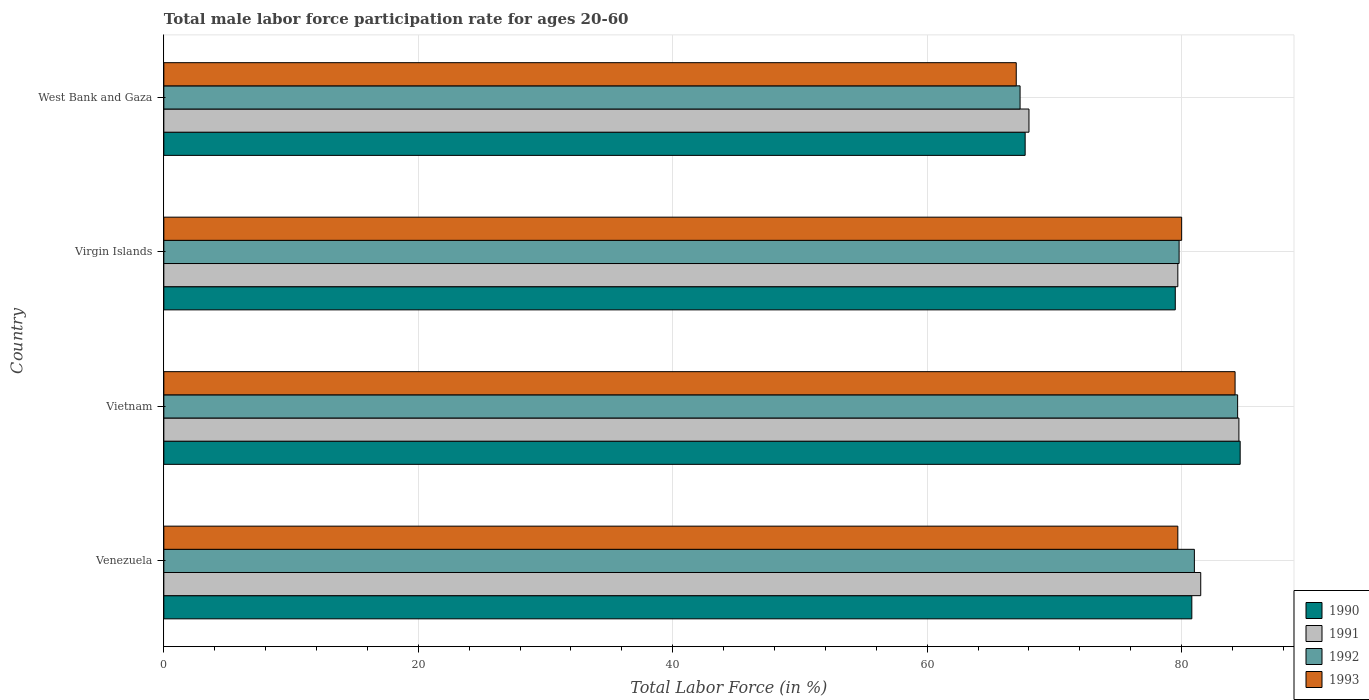How many bars are there on the 4th tick from the top?
Your response must be concise. 4. How many bars are there on the 4th tick from the bottom?
Your response must be concise. 4. What is the label of the 2nd group of bars from the top?
Your answer should be very brief. Virgin Islands. What is the male labor force participation rate in 1993 in Vietnam?
Give a very brief answer. 84.2. Across all countries, what is the maximum male labor force participation rate in 1992?
Give a very brief answer. 84.4. In which country was the male labor force participation rate in 1991 maximum?
Your response must be concise. Vietnam. In which country was the male labor force participation rate in 1992 minimum?
Your response must be concise. West Bank and Gaza. What is the total male labor force participation rate in 1990 in the graph?
Keep it short and to the point. 312.6. What is the difference between the male labor force participation rate in 1993 in Virgin Islands and that in West Bank and Gaza?
Make the answer very short. 13. What is the difference between the male labor force participation rate in 1992 in Virgin Islands and the male labor force participation rate in 1993 in Venezuela?
Your answer should be very brief. 0.1. What is the average male labor force participation rate in 1993 per country?
Give a very brief answer. 77.72. What is the difference between the male labor force participation rate in 1991 and male labor force participation rate in 1993 in Venezuela?
Make the answer very short. 1.8. What is the ratio of the male labor force participation rate in 1993 in Vietnam to that in Virgin Islands?
Offer a very short reply. 1.05. Is the male labor force participation rate in 1990 in Vietnam less than that in Virgin Islands?
Provide a short and direct response. No. Is the difference between the male labor force participation rate in 1991 in Venezuela and Vietnam greater than the difference between the male labor force participation rate in 1993 in Venezuela and Vietnam?
Give a very brief answer. Yes. What is the difference between the highest and the second highest male labor force participation rate in 1991?
Offer a very short reply. 3. What is the difference between the highest and the lowest male labor force participation rate in 1993?
Your response must be concise. 17.2. Is it the case that in every country, the sum of the male labor force participation rate in 1992 and male labor force participation rate in 1993 is greater than the male labor force participation rate in 1990?
Ensure brevity in your answer.  Yes. Are all the bars in the graph horizontal?
Provide a succinct answer. Yes. How many countries are there in the graph?
Provide a short and direct response. 4. Are the values on the major ticks of X-axis written in scientific E-notation?
Ensure brevity in your answer.  No. Does the graph contain any zero values?
Offer a very short reply. No. Does the graph contain grids?
Offer a very short reply. Yes. Where does the legend appear in the graph?
Make the answer very short. Bottom right. How many legend labels are there?
Your answer should be very brief. 4. What is the title of the graph?
Your answer should be very brief. Total male labor force participation rate for ages 20-60. What is the label or title of the X-axis?
Ensure brevity in your answer.  Total Labor Force (in %). What is the label or title of the Y-axis?
Offer a very short reply. Country. What is the Total Labor Force (in %) in 1990 in Venezuela?
Give a very brief answer. 80.8. What is the Total Labor Force (in %) of 1991 in Venezuela?
Offer a very short reply. 81.5. What is the Total Labor Force (in %) in 1992 in Venezuela?
Your answer should be compact. 81. What is the Total Labor Force (in %) of 1993 in Venezuela?
Offer a very short reply. 79.7. What is the Total Labor Force (in %) in 1990 in Vietnam?
Offer a very short reply. 84.6. What is the Total Labor Force (in %) in 1991 in Vietnam?
Offer a terse response. 84.5. What is the Total Labor Force (in %) of 1992 in Vietnam?
Provide a short and direct response. 84.4. What is the Total Labor Force (in %) of 1993 in Vietnam?
Your answer should be compact. 84.2. What is the Total Labor Force (in %) of 1990 in Virgin Islands?
Provide a succinct answer. 79.5. What is the Total Labor Force (in %) in 1991 in Virgin Islands?
Give a very brief answer. 79.7. What is the Total Labor Force (in %) in 1992 in Virgin Islands?
Your answer should be very brief. 79.8. What is the Total Labor Force (in %) of 1990 in West Bank and Gaza?
Offer a very short reply. 67.7. What is the Total Labor Force (in %) of 1991 in West Bank and Gaza?
Your answer should be compact. 68. What is the Total Labor Force (in %) of 1992 in West Bank and Gaza?
Provide a succinct answer. 67.3. Across all countries, what is the maximum Total Labor Force (in %) of 1990?
Give a very brief answer. 84.6. Across all countries, what is the maximum Total Labor Force (in %) of 1991?
Make the answer very short. 84.5. Across all countries, what is the maximum Total Labor Force (in %) in 1992?
Your answer should be compact. 84.4. Across all countries, what is the maximum Total Labor Force (in %) in 1993?
Provide a succinct answer. 84.2. Across all countries, what is the minimum Total Labor Force (in %) in 1990?
Offer a terse response. 67.7. Across all countries, what is the minimum Total Labor Force (in %) in 1992?
Make the answer very short. 67.3. What is the total Total Labor Force (in %) in 1990 in the graph?
Give a very brief answer. 312.6. What is the total Total Labor Force (in %) in 1991 in the graph?
Ensure brevity in your answer.  313.7. What is the total Total Labor Force (in %) in 1992 in the graph?
Ensure brevity in your answer.  312.5. What is the total Total Labor Force (in %) of 1993 in the graph?
Make the answer very short. 310.9. What is the difference between the Total Labor Force (in %) of 1990 in Venezuela and that in Vietnam?
Make the answer very short. -3.8. What is the difference between the Total Labor Force (in %) of 1991 in Venezuela and that in Virgin Islands?
Make the answer very short. 1.8. What is the difference between the Total Labor Force (in %) in 1992 in Venezuela and that in West Bank and Gaza?
Keep it short and to the point. 13.7. What is the difference between the Total Labor Force (in %) of 1993 in Venezuela and that in West Bank and Gaza?
Provide a short and direct response. 12.7. What is the difference between the Total Labor Force (in %) of 1991 in Vietnam and that in Virgin Islands?
Make the answer very short. 4.8. What is the difference between the Total Labor Force (in %) of 1992 in Vietnam and that in Virgin Islands?
Your answer should be compact. 4.6. What is the difference between the Total Labor Force (in %) of 1990 in Vietnam and that in West Bank and Gaza?
Provide a succinct answer. 16.9. What is the difference between the Total Labor Force (in %) of 1992 in Vietnam and that in West Bank and Gaza?
Offer a very short reply. 17.1. What is the difference between the Total Labor Force (in %) in 1990 in Virgin Islands and that in West Bank and Gaza?
Offer a terse response. 11.8. What is the difference between the Total Labor Force (in %) in 1990 in Venezuela and the Total Labor Force (in %) in 1991 in Vietnam?
Keep it short and to the point. -3.7. What is the difference between the Total Labor Force (in %) of 1990 in Venezuela and the Total Labor Force (in %) of 1992 in Vietnam?
Offer a very short reply. -3.6. What is the difference between the Total Labor Force (in %) of 1990 in Venezuela and the Total Labor Force (in %) of 1993 in Vietnam?
Your answer should be very brief. -3.4. What is the difference between the Total Labor Force (in %) of 1991 in Venezuela and the Total Labor Force (in %) of 1993 in Vietnam?
Make the answer very short. -2.7. What is the difference between the Total Labor Force (in %) in 1992 in Venezuela and the Total Labor Force (in %) in 1993 in Vietnam?
Provide a succinct answer. -3.2. What is the difference between the Total Labor Force (in %) in 1990 in Venezuela and the Total Labor Force (in %) in 1991 in Virgin Islands?
Give a very brief answer. 1.1. What is the difference between the Total Labor Force (in %) in 1990 in Venezuela and the Total Labor Force (in %) in 1992 in Virgin Islands?
Your response must be concise. 1. What is the difference between the Total Labor Force (in %) of 1990 in Venezuela and the Total Labor Force (in %) of 1992 in West Bank and Gaza?
Ensure brevity in your answer.  13.5. What is the difference between the Total Labor Force (in %) in 1991 in Venezuela and the Total Labor Force (in %) in 1992 in West Bank and Gaza?
Offer a very short reply. 14.2. What is the difference between the Total Labor Force (in %) in 1990 in Vietnam and the Total Labor Force (in %) in 1992 in Virgin Islands?
Offer a terse response. 4.8. What is the difference between the Total Labor Force (in %) in 1990 in Vietnam and the Total Labor Force (in %) in 1993 in Virgin Islands?
Keep it short and to the point. 4.6. What is the difference between the Total Labor Force (in %) in 1991 in Vietnam and the Total Labor Force (in %) in 1992 in Virgin Islands?
Your response must be concise. 4.7. What is the difference between the Total Labor Force (in %) in 1992 in Vietnam and the Total Labor Force (in %) in 1993 in Virgin Islands?
Your answer should be compact. 4.4. What is the difference between the Total Labor Force (in %) in 1990 in Vietnam and the Total Labor Force (in %) in 1991 in West Bank and Gaza?
Ensure brevity in your answer.  16.6. What is the difference between the Total Labor Force (in %) of 1990 in Vietnam and the Total Labor Force (in %) of 1992 in West Bank and Gaza?
Keep it short and to the point. 17.3. What is the difference between the Total Labor Force (in %) in 1990 in Vietnam and the Total Labor Force (in %) in 1993 in West Bank and Gaza?
Keep it short and to the point. 17.6. What is the difference between the Total Labor Force (in %) in 1990 in Virgin Islands and the Total Labor Force (in %) in 1991 in West Bank and Gaza?
Provide a succinct answer. 11.5. What is the difference between the Total Labor Force (in %) in 1990 in Virgin Islands and the Total Labor Force (in %) in 1992 in West Bank and Gaza?
Your response must be concise. 12.2. What is the difference between the Total Labor Force (in %) in 1990 in Virgin Islands and the Total Labor Force (in %) in 1993 in West Bank and Gaza?
Give a very brief answer. 12.5. What is the difference between the Total Labor Force (in %) in 1991 in Virgin Islands and the Total Labor Force (in %) in 1992 in West Bank and Gaza?
Ensure brevity in your answer.  12.4. What is the difference between the Total Labor Force (in %) in 1991 in Virgin Islands and the Total Labor Force (in %) in 1993 in West Bank and Gaza?
Offer a terse response. 12.7. What is the difference between the Total Labor Force (in %) of 1992 in Virgin Islands and the Total Labor Force (in %) of 1993 in West Bank and Gaza?
Offer a terse response. 12.8. What is the average Total Labor Force (in %) of 1990 per country?
Give a very brief answer. 78.15. What is the average Total Labor Force (in %) of 1991 per country?
Give a very brief answer. 78.42. What is the average Total Labor Force (in %) in 1992 per country?
Provide a short and direct response. 78.12. What is the average Total Labor Force (in %) in 1993 per country?
Your answer should be very brief. 77.72. What is the difference between the Total Labor Force (in %) in 1990 and Total Labor Force (in %) in 1991 in Venezuela?
Your answer should be compact. -0.7. What is the difference between the Total Labor Force (in %) in 1991 and Total Labor Force (in %) in 1992 in Venezuela?
Offer a terse response. 0.5. What is the difference between the Total Labor Force (in %) of 1991 and Total Labor Force (in %) of 1993 in Venezuela?
Provide a short and direct response. 1.8. What is the difference between the Total Labor Force (in %) in 1990 and Total Labor Force (in %) in 1992 in Vietnam?
Offer a very short reply. 0.2. What is the difference between the Total Labor Force (in %) in 1992 and Total Labor Force (in %) in 1993 in Vietnam?
Offer a terse response. 0.2. What is the difference between the Total Labor Force (in %) of 1990 and Total Labor Force (in %) of 1991 in Virgin Islands?
Your answer should be compact. -0.2. What is the difference between the Total Labor Force (in %) of 1990 and Total Labor Force (in %) of 1993 in Virgin Islands?
Offer a very short reply. -0.5. What is the difference between the Total Labor Force (in %) of 1991 and Total Labor Force (in %) of 1993 in Virgin Islands?
Provide a short and direct response. -0.3. What is the difference between the Total Labor Force (in %) in 1990 and Total Labor Force (in %) in 1991 in West Bank and Gaza?
Provide a short and direct response. -0.3. What is the difference between the Total Labor Force (in %) of 1990 and Total Labor Force (in %) of 1992 in West Bank and Gaza?
Make the answer very short. 0.4. What is the difference between the Total Labor Force (in %) of 1991 and Total Labor Force (in %) of 1992 in West Bank and Gaza?
Your answer should be compact. 0.7. What is the difference between the Total Labor Force (in %) in 1991 and Total Labor Force (in %) in 1993 in West Bank and Gaza?
Keep it short and to the point. 1. What is the difference between the Total Labor Force (in %) of 1992 and Total Labor Force (in %) of 1993 in West Bank and Gaza?
Ensure brevity in your answer.  0.3. What is the ratio of the Total Labor Force (in %) of 1990 in Venezuela to that in Vietnam?
Provide a short and direct response. 0.96. What is the ratio of the Total Labor Force (in %) of 1991 in Venezuela to that in Vietnam?
Give a very brief answer. 0.96. What is the ratio of the Total Labor Force (in %) of 1992 in Venezuela to that in Vietnam?
Offer a terse response. 0.96. What is the ratio of the Total Labor Force (in %) in 1993 in Venezuela to that in Vietnam?
Your answer should be compact. 0.95. What is the ratio of the Total Labor Force (in %) in 1990 in Venezuela to that in Virgin Islands?
Make the answer very short. 1.02. What is the ratio of the Total Labor Force (in %) in 1991 in Venezuela to that in Virgin Islands?
Ensure brevity in your answer.  1.02. What is the ratio of the Total Labor Force (in %) in 1992 in Venezuela to that in Virgin Islands?
Your answer should be compact. 1.01. What is the ratio of the Total Labor Force (in %) in 1993 in Venezuela to that in Virgin Islands?
Your response must be concise. 1. What is the ratio of the Total Labor Force (in %) of 1990 in Venezuela to that in West Bank and Gaza?
Provide a short and direct response. 1.19. What is the ratio of the Total Labor Force (in %) in 1991 in Venezuela to that in West Bank and Gaza?
Your answer should be very brief. 1.2. What is the ratio of the Total Labor Force (in %) in 1992 in Venezuela to that in West Bank and Gaza?
Keep it short and to the point. 1.2. What is the ratio of the Total Labor Force (in %) in 1993 in Venezuela to that in West Bank and Gaza?
Give a very brief answer. 1.19. What is the ratio of the Total Labor Force (in %) of 1990 in Vietnam to that in Virgin Islands?
Your answer should be very brief. 1.06. What is the ratio of the Total Labor Force (in %) of 1991 in Vietnam to that in Virgin Islands?
Offer a very short reply. 1.06. What is the ratio of the Total Labor Force (in %) of 1992 in Vietnam to that in Virgin Islands?
Provide a succinct answer. 1.06. What is the ratio of the Total Labor Force (in %) of 1993 in Vietnam to that in Virgin Islands?
Offer a very short reply. 1.05. What is the ratio of the Total Labor Force (in %) in 1990 in Vietnam to that in West Bank and Gaza?
Keep it short and to the point. 1.25. What is the ratio of the Total Labor Force (in %) in 1991 in Vietnam to that in West Bank and Gaza?
Ensure brevity in your answer.  1.24. What is the ratio of the Total Labor Force (in %) of 1992 in Vietnam to that in West Bank and Gaza?
Provide a short and direct response. 1.25. What is the ratio of the Total Labor Force (in %) in 1993 in Vietnam to that in West Bank and Gaza?
Offer a very short reply. 1.26. What is the ratio of the Total Labor Force (in %) of 1990 in Virgin Islands to that in West Bank and Gaza?
Keep it short and to the point. 1.17. What is the ratio of the Total Labor Force (in %) of 1991 in Virgin Islands to that in West Bank and Gaza?
Make the answer very short. 1.17. What is the ratio of the Total Labor Force (in %) in 1992 in Virgin Islands to that in West Bank and Gaza?
Ensure brevity in your answer.  1.19. What is the ratio of the Total Labor Force (in %) of 1993 in Virgin Islands to that in West Bank and Gaza?
Make the answer very short. 1.19. 